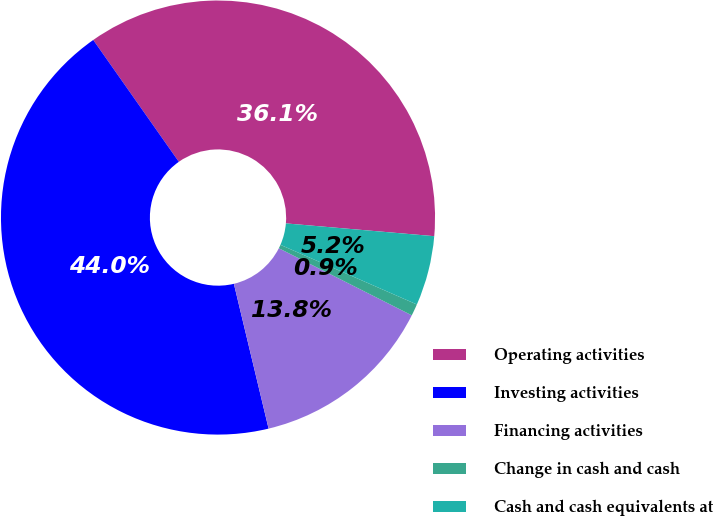Convert chart. <chart><loc_0><loc_0><loc_500><loc_500><pie_chart><fcel>Operating activities<fcel>Investing activities<fcel>Financing activities<fcel>Change in cash and cash<fcel>Cash and cash equivalents at<nl><fcel>36.12%<fcel>44.0%<fcel>13.82%<fcel>0.88%<fcel>5.19%<nl></chart> 